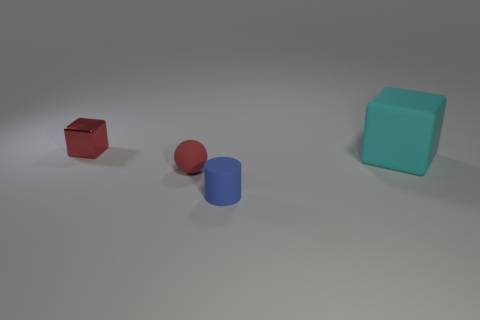Add 3 large green matte spheres. How many objects exist? 7 Subtract all spheres. How many objects are left? 3 Subtract all big cubes. Subtract all large cyan things. How many objects are left? 2 Add 4 rubber cylinders. How many rubber cylinders are left? 5 Add 4 matte cylinders. How many matte cylinders exist? 5 Subtract 0 purple cubes. How many objects are left? 4 